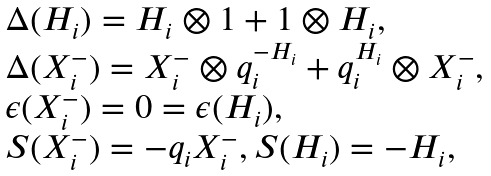Convert formula to latex. <formula><loc_0><loc_0><loc_500><loc_500>\begin{array} { l } { { \Delta ( H _ { i } ) = H _ { i } \otimes 1 + 1 \otimes H _ { i } , } } \\ { { \Delta ( X _ { i } ^ { - } ) = X _ { i } ^ { - } \otimes q _ { i } ^ { - H _ { i } } + q _ { i } ^ { H _ { i } } \otimes X _ { i } ^ { - } , } } \\ { { \epsilon ( X _ { i } ^ { - } ) = 0 = \epsilon ( H _ { i } ) , } } \\ { { S ( X _ { i } ^ { - } ) = - q _ { i } X _ { i } ^ { - } , S ( H _ { i } ) = - H _ { i } , } } \end{array}</formula> 